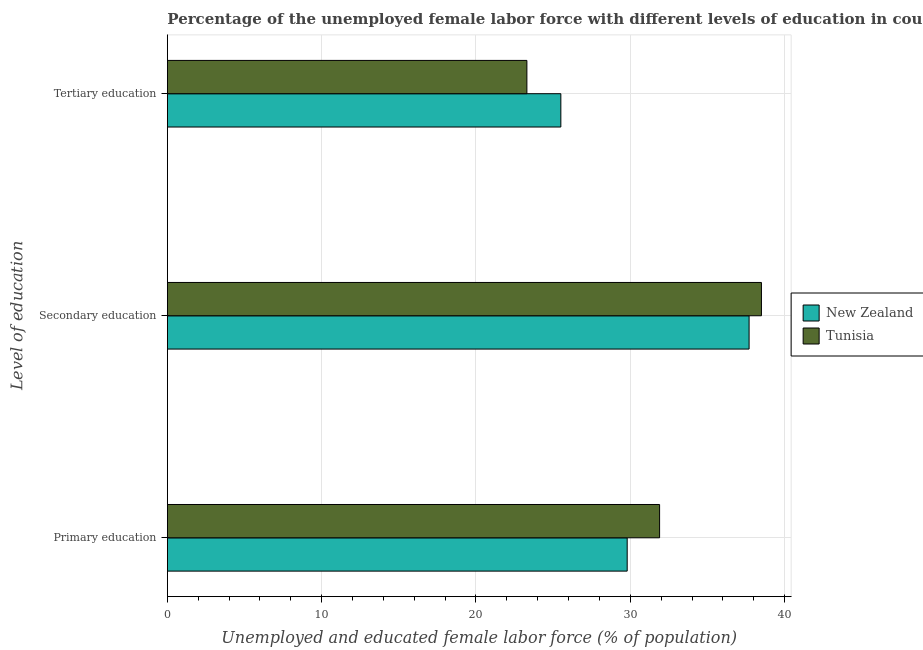How many groups of bars are there?
Provide a short and direct response. 3. How many bars are there on the 3rd tick from the top?
Provide a short and direct response. 2. What is the percentage of female labor force who received secondary education in New Zealand?
Give a very brief answer. 37.7. Across all countries, what is the maximum percentage of female labor force who received secondary education?
Offer a terse response. 38.5. Across all countries, what is the minimum percentage of female labor force who received tertiary education?
Give a very brief answer. 23.3. In which country was the percentage of female labor force who received primary education maximum?
Provide a succinct answer. Tunisia. In which country was the percentage of female labor force who received tertiary education minimum?
Keep it short and to the point. Tunisia. What is the total percentage of female labor force who received primary education in the graph?
Offer a terse response. 61.7. What is the difference between the percentage of female labor force who received primary education in Tunisia and that in New Zealand?
Give a very brief answer. 2.1. What is the average percentage of female labor force who received secondary education per country?
Offer a very short reply. 38.1. What is the difference between the percentage of female labor force who received tertiary education and percentage of female labor force who received secondary education in Tunisia?
Provide a short and direct response. -15.2. What is the ratio of the percentage of female labor force who received primary education in New Zealand to that in Tunisia?
Ensure brevity in your answer.  0.93. Is the difference between the percentage of female labor force who received primary education in New Zealand and Tunisia greater than the difference between the percentage of female labor force who received tertiary education in New Zealand and Tunisia?
Give a very brief answer. No. What is the difference between the highest and the second highest percentage of female labor force who received tertiary education?
Keep it short and to the point. 2.2. What is the difference between the highest and the lowest percentage of female labor force who received secondary education?
Give a very brief answer. 0.8. In how many countries, is the percentage of female labor force who received secondary education greater than the average percentage of female labor force who received secondary education taken over all countries?
Your answer should be compact. 1. Is the sum of the percentage of female labor force who received tertiary education in New Zealand and Tunisia greater than the maximum percentage of female labor force who received secondary education across all countries?
Make the answer very short. Yes. What does the 2nd bar from the top in Tertiary education represents?
Provide a short and direct response. New Zealand. What does the 1st bar from the bottom in Secondary education represents?
Give a very brief answer. New Zealand. Is it the case that in every country, the sum of the percentage of female labor force who received primary education and percentage of female labor force who received secondary education is greater than the percentage of female labor force who received tertiary education?
Provide a short and direct response. Yes. How many bars are there?
Offer a very short reply. 6. Are all the bars in the graph horizontal?
Offer a very short reply. Yes. How many countries are there in the graph?
Make the answer very short. 2. What is the difference between two consecutive major ticks on the X-axis?
Offer a terse response. 10. Does the graph contain any zero values?
Give a very brief answer. No. How many legend labels are there?
Make the answer very short. 2. How are the legend labels stacked?
Provide a short and direct response. Vertical. What is the title of the graph?
Keep it short and to the point. Percentage of the unemployed female labor force with different levels of education in countries. Does "Malta" appear as one of the legend labels in the graph?
Keep it short and to the point. No. What is the label or title of the X-axis?
Provide a succinct answer. Unemployed and educated female labor force (% of population). What is the label or title of the Y-axis?
Provide a short and direct response. Level of education. What is the Unemployed and educated female labor force (% of population) in New Zealand in Primary education?
Provide a short and direct response. 29.8. What is the Unemployed and educated female labor force (% of population) in Tunisia in Primary education?
Provide a short and direct response. 31.9. What is the Unemployed and educated female labor force (% of population) of New Zealand in Secondary education?
Your answer should be very brief. 37.7. What is the Unemployed and educated female labor force (% of population) in Tunisia in Secondary education?
Your response must be concise. 38.5. What is the Unemployed and educated female labor force (% of population) in Tunisia in Tertiary education?
Give a very brief answer. 23.3. Across all Level of education, what is the maximum Unemployed and educated female labor force (% of population) in New Zealand?
Provide a succinct answer. 37.7. Across all Level of education, what is the maximum Unemployed and educated female labor force (% of population) in Tunisia?
Provide a succinct answer. 38.5. Across all Level of education, what is the minimum Unemployed and educated female labor force (% of population) of New Zealand?
Keep it short and to the point. 25.5. Across all Level of education, what is the minimum Unemployed and educated female labor force (% of population) of Tunisia?
Give a very brief answer. 23.3. What is the total Unemployed and educated female labor force (% of population) of New Zealand in the graph?
Your response must be concise. 93. What is the total Unemployed and educated female labor force (% of population) in Tunisia in the graph?
Your answer should be very brief. 93.7. What is the difference between the Unemployed and educated female labor force (% of population) of Tunisia in Primary education and that in Secondary education?
Keep it short and to the point. -6.6. What is the difference between the Unemployed and educated female labor force (% of population) of New Zealand in Secondary education and that in Tertiary education?
Provide a succinct answer. 12.2. What is the difference between the Unemployed and educated female labor force (% of population) in New Zealand in Primary education and the Unemployed and educated female labor force (% of population) in Tunisia in Secondary education?
Ensure brevity in your answer.  -8.7. What is the difference between the Unemployed and educated female labor force (% of population) of New Zealand in Secondary education and the Unemployed and educated female labor force (% of population) of Tunisia in Tertiary education?
Provide a succinct answer. 14.4. What is the average Unemployed and educated female labor force (% of population) of Tunisia per Level of education?
Offer a very short reply. 31.23. What is the ratio of the Unemployed and educated female labor force (% of population) in New Zealand in Primary education to that in Secondary education?
Offer a terse response. 0.79. What is the ratio of the Unemployed and educated female labor force (% of population) in Tunisia in Primary education to that in Secondary education?
Offer a very short reply. 0.83. What is the ratio of the Unemployed and educated female labor force (% of population) in New Zealand in Primary education to that in Tertiary education?
Your answer should be very brief. 1.17. What is the ratio of the Unemployed and educated female labor force (% of population) in Tunisia in Primary education to that in Tertiary education?
Ensure brevity in your answer.  1.37. What is the ratio of the Unemployed and educated female labor force (% of population) of New Zealand in Secondary education to that in Tertiary education?
Offer a terse response. 1.48. What is the ratio of the Unemployed and educated female labor force (% of population) in Tunisia in Secondary education to that in Tertiary education?
Your answer should be very brief. 1.65. What is the difference between the highest and the second highest Unemployed and educated female labor force (% of population) of New Zealand?
Keep it short and to the point. 7.9. What is the difference between the highest and the second highest Unemployed and educated female labor force (% of population) of Tunisia?
Make the answer very short. 6.6. 